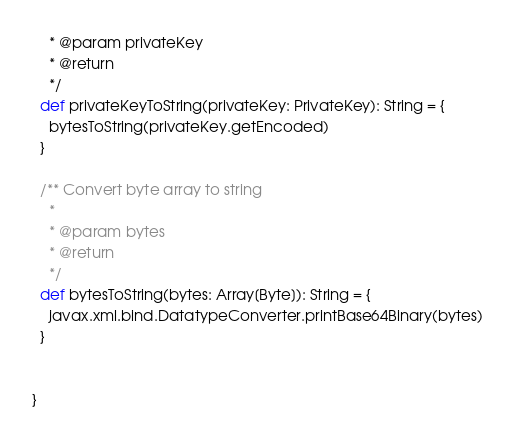Convert code to text. <code><loc_0><loc_0><loc_500><loc_500><_Scala_>    * @param privateKey
    * @return
    */
  def privateKeyToString(privateKey: PrivateKey): String = {
    bytesToString(privateKey.getEncoded)
  }

  /** Convert byte array to string
    *
    * @param bytes
    * @return
    */
  def bytesToString(bytes: Array[Byte]): String = {
    javax.xml.bind.DatatypeConverter.printBase64Binary(bytes)
  }


}
</code> 